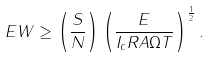<formula> <loc_0><loc_0><loc_500><loc_500>E W \geq \left ( \frac { S } { N } \right ) \left ( \frac { E } { I _ { c } R A \Omega T } \right ) ^ { \frac { 1 } { 2 } } .</formula> 